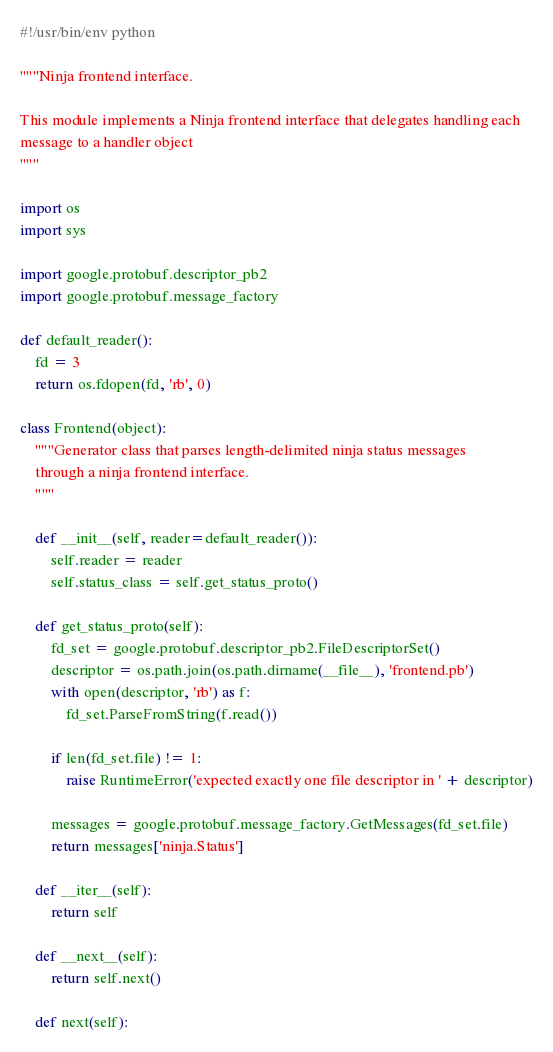<code> <loc_0><loc_0><loc_500><loc_500><_Python_>#!/usr/bin/env python

"""Ninja frontend interface.

This module implements a Ninja frontend interface that delegates handling each
message to a handler object
"""

import os
import sys

import google.protobuf.descriptor_pb2
import google.protobuf.message_factory

def default_reader():
    fd = 3
    return os.fdopen(fd, 'rb', 0)

class Frontend(object):
    """Generator class that parses length-delimited ninja status messages
    through a ninja frontend interface.
    """

    def __init__(self, reader=default_reader()):
        self.reader = reader
        self.status_class = self.get_status_proto()

    def get_status_proto(self):
        fd_set = google.protobuf.descriptor_pb2.FileDescriptorSet()
        descriptor = os.path.join(os.path.dirname(__file__), 'frontend.pb')
        with open(descriptor, 'rb') as f:
            fd_set.ParseFromString(f.read())

        if len(fd_set.file) != 1:
            raise RuntimeError('expected exactly one file descriptor in ' + descriptor)

        messages = google.protobuf.message_factory.GetMessages(fd_set.file)
        return messages['ninja.Status']

    def __iter__(self):
        return self

    def __next__(self):
        return self.next()

    def next(self):</code> 